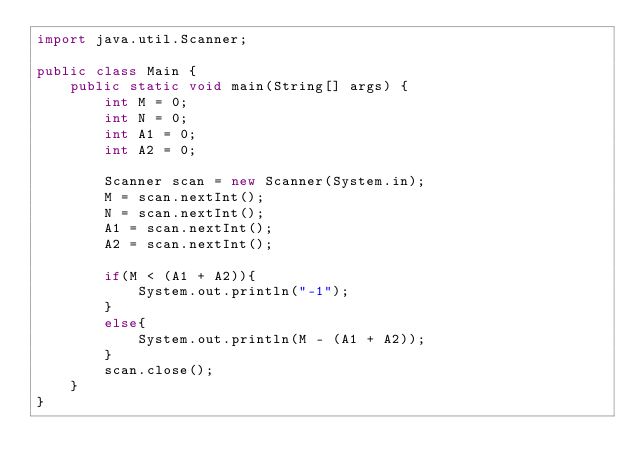<code> <loc_0><loc_0><loc_500><loc_500><_Java_>import java.util.Scanner;
 
public class Main {
    public static void main(String[] args) {
        int M = 0;
        int N = 0;
        int A1 = 0;
        int A2 = 0;

        Scanner scan = new Scanner(System.in);
        M = scan.nextInt();
        N = scan.nextInt();
        A1 = scan.nextInt();
        A2 = scan.nextInt();
        
        if(M < (A1 + A2)){
            System.out.println("-1");
        }
        else{
            System.out.println(M - (A1 + A2));
        }
        scan.close();
    }
}</code> 